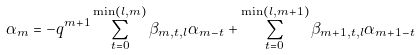<formula> <loc_0><loc_0><loc_500><loc_500>\alpha _ { m } = - q ^ { m + 1 } \sum _ { t = 0 } ^ { \min ( l , m ) } \beta _ { m , t , l } \alpha _ { m - t } + \sum _ { t = 0 } ^ { \min ( l , m + 1 ) } \beta _ { m + 1 , t , l } \alpha _ { m + 1 - t }</formula> 